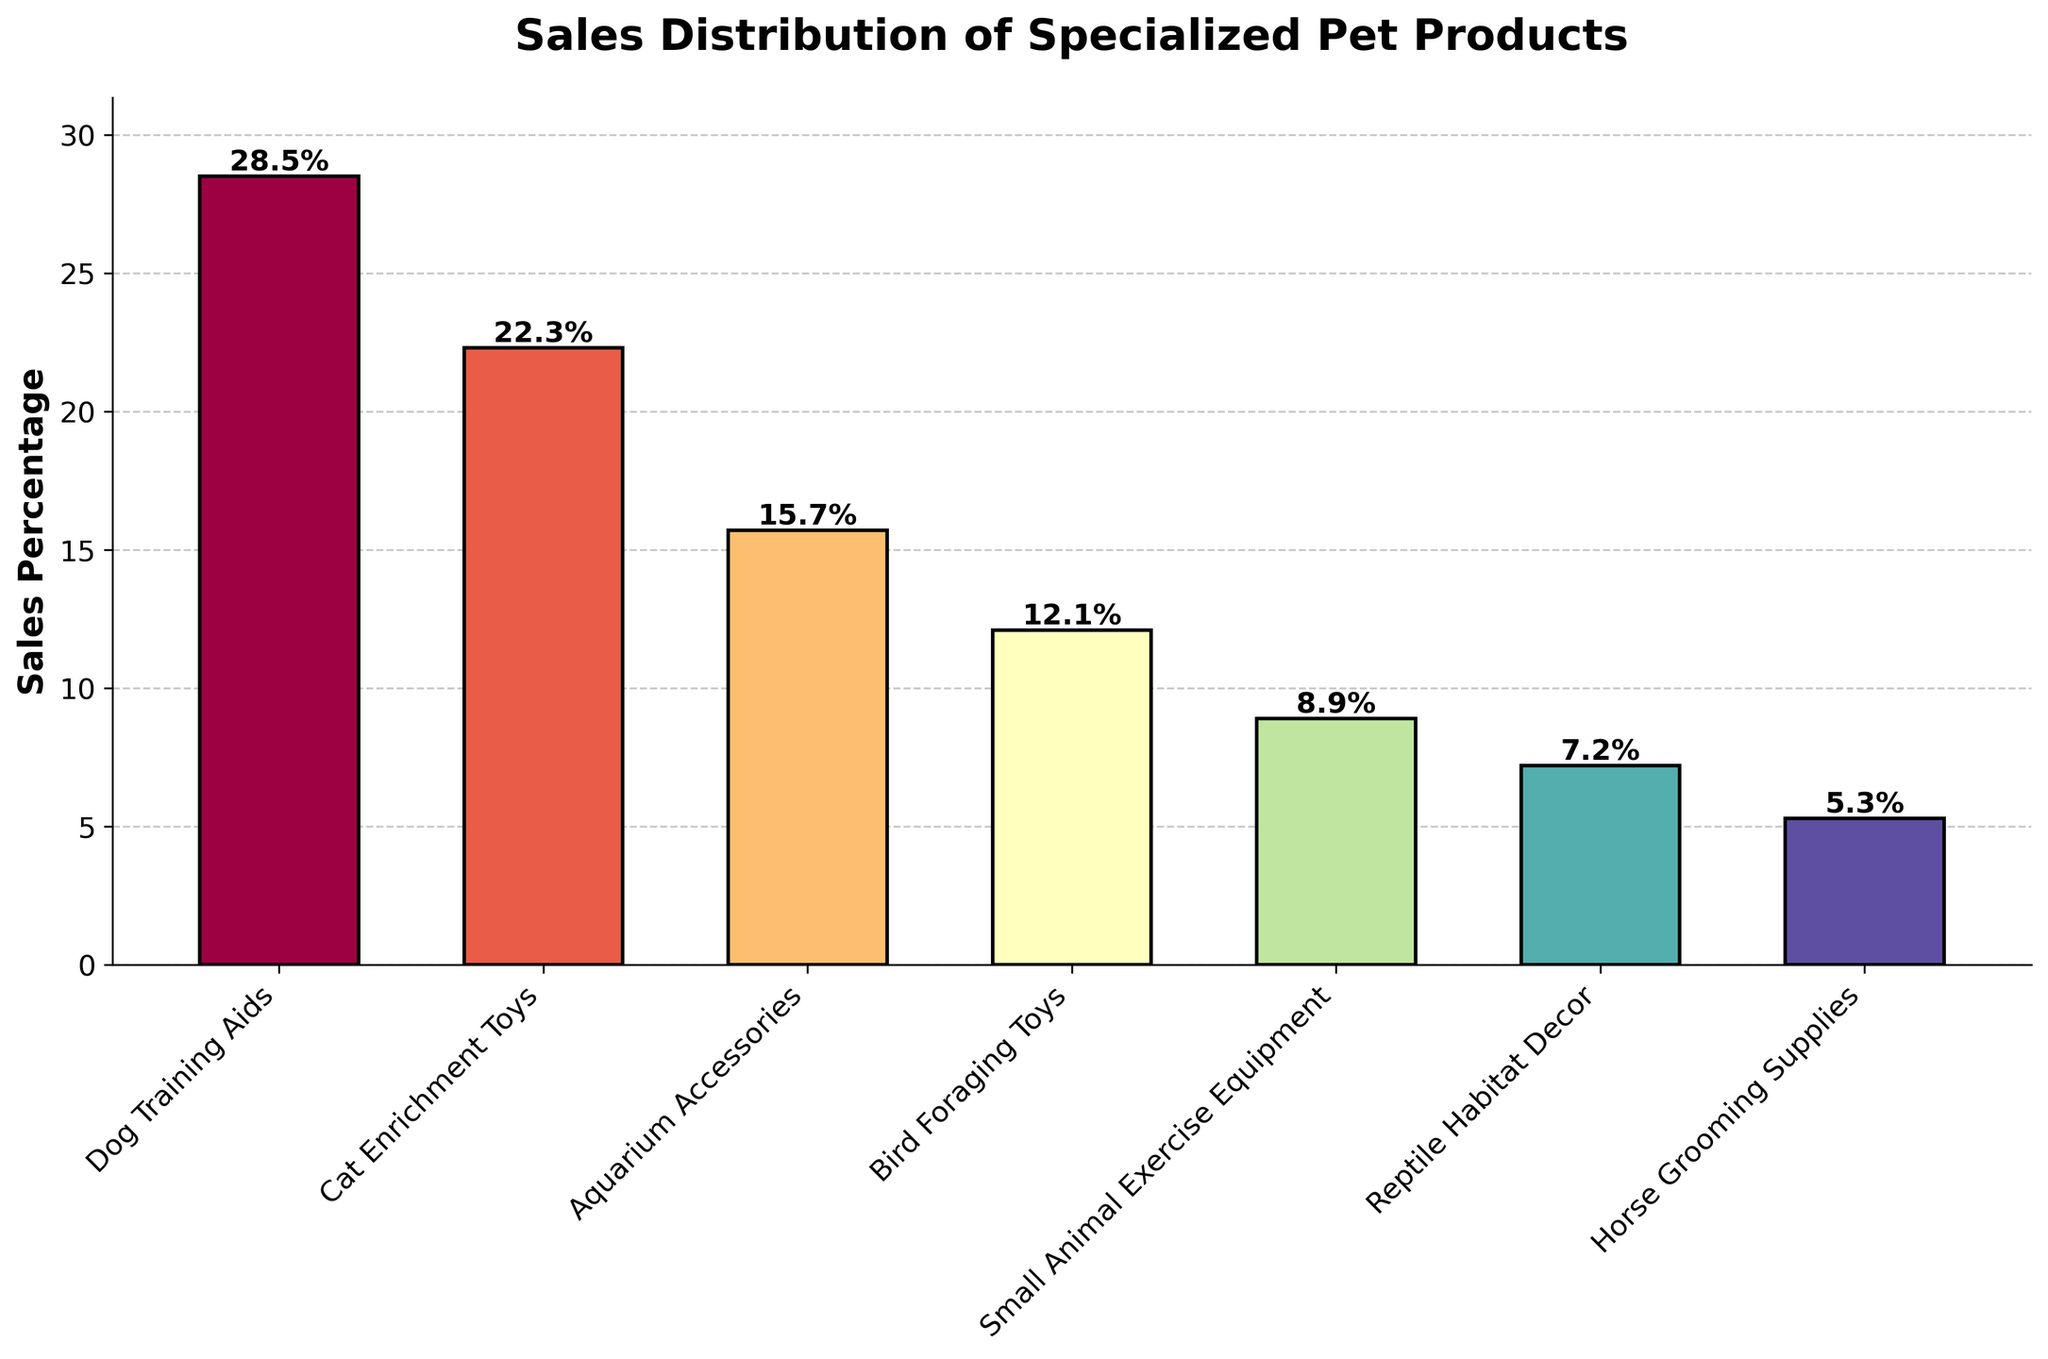What's the highest sales percentage category in the plot? The bar chart shows the sales percentages for various categories. The tallest bar will indicate the highest sales percentage, which is "Dog Training Aids" at 28.5%.
Answer: Dog Training Aids Which category has the lowest sales percentage? By identifying the shortest bar on the plot, you can determine the category with the lowest sales percentage, which is "Horse Grooming Supplies" at 5.3%.
Answer: Horse Grooming Supplies How do the sales percentages of "Aquarium Accessories" and "Bird Foraging Toys" compare? Looking at the heights of the bars, "Aquarium Accessories" has a sales percentage of 15.7%, and "Bird Foraging Toys" has 12.1%. Therefore, "Aquarium Accessories" has a higher sales percentage than "Bird Foraging Toys".
Answer: Aquarium Accessories is higher What is the total sales percentage for all categories combined? Adding up all the sales percentages: (28.5 + 22.3 + 15.7 + 12.1 + 8.9 + 7.2 + 5.3) equals 100%. This means the total sales percentage for all categories combined is 100%.
Answer: 100% Which category lies at the median of the sales distribution? To find the median, list the percentages in ascending order: 5.3, 7.2, 8.9, 12.1, 15.7, 22.3, 28.5. The median value (middle number) is 12.1, corresponding to "Bird Foraging Toys".
Answer: Bird Foraging Toys What is the difference in sales percentage between "Dog Training Aids" and "Cat Enrichment Toys"? Subtract the sales percentage of "Cat Enrichment Toys" from "Dog Training Aids": 28.5% - 22.3% = 6.2%.
Answer: 6.2% If you combine the sales percentages of "Small Animal Exercise Equipment" and "Reptile Habitat Decor", what do you get? Adding the sales percentages of "Small Animal Exercise Equipment" (8.9%) and "Reptile Habitat Decor" (7.2%) gives 8.9 + 7.2 = 16.1%.
Answer: 16.1% Which bar is colored to indicate the third-highest sales percentage, and what is that percentage? Locate the third tallest bar in the plot, which corresponds to "Aquarium Accessories" with a sales percentage of 15.7%.
Answer: Aquarium Accessories, 15.7% What is the average sales percentage across all animal categories? Sum the percentages (28.5 + 22.3 + 15.7 + 12.1 + 8.9 + 7.2 + 5.3) to get 100, then divide by the total number of categories, which is 7: 100 / 7 ≈ 14.29%.
Answer: 14.29% How many categories have less than 10% sales percentage? By identifying and counting the bars with heights less than 10%: "Small Animal Exercise Equipment", "Reptile Habitat Decor", and "Horse Grooming Supplies", there are three such categories.
Answer: 3 categories 